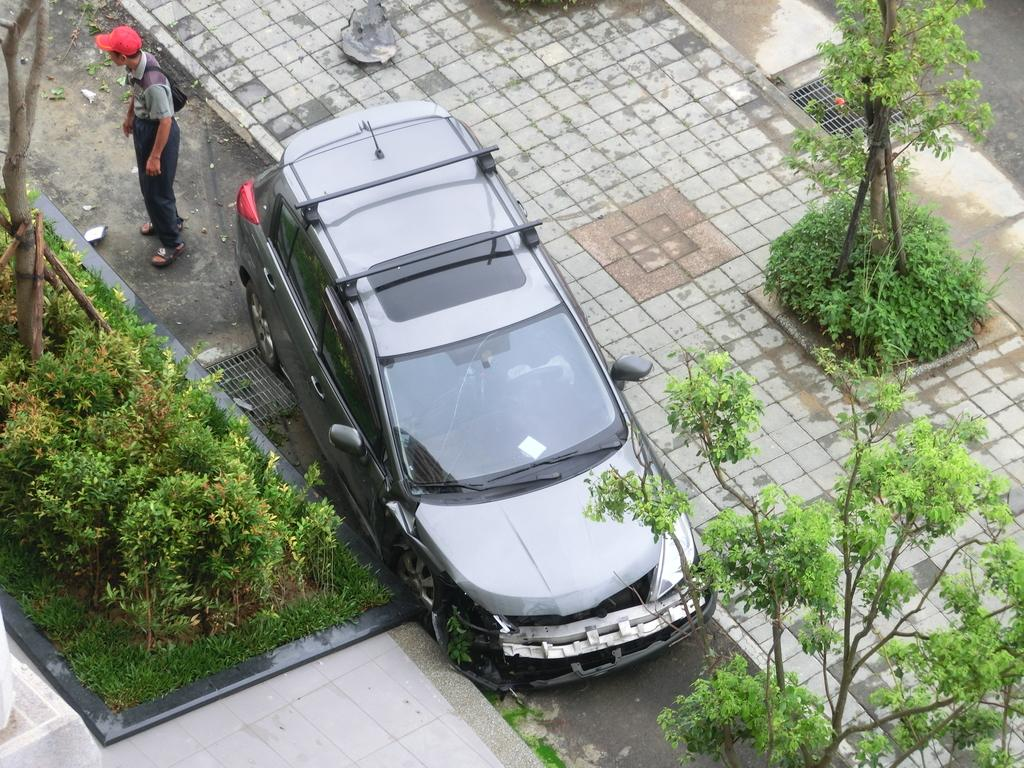What is the main subject of the image? There is a car at the center of the image. What type of vegetation can be seen on the right side of the image? There are trees on the right side of the image. What type of vegetation can be seen on the left side of the image? There are bushes on the left side of the image. Can you describe the person visible in the image? There is a man visible at the top of the image. How many cows are grazing in the oatmeal in the image? There are no cows or oatmeal present in the image. 